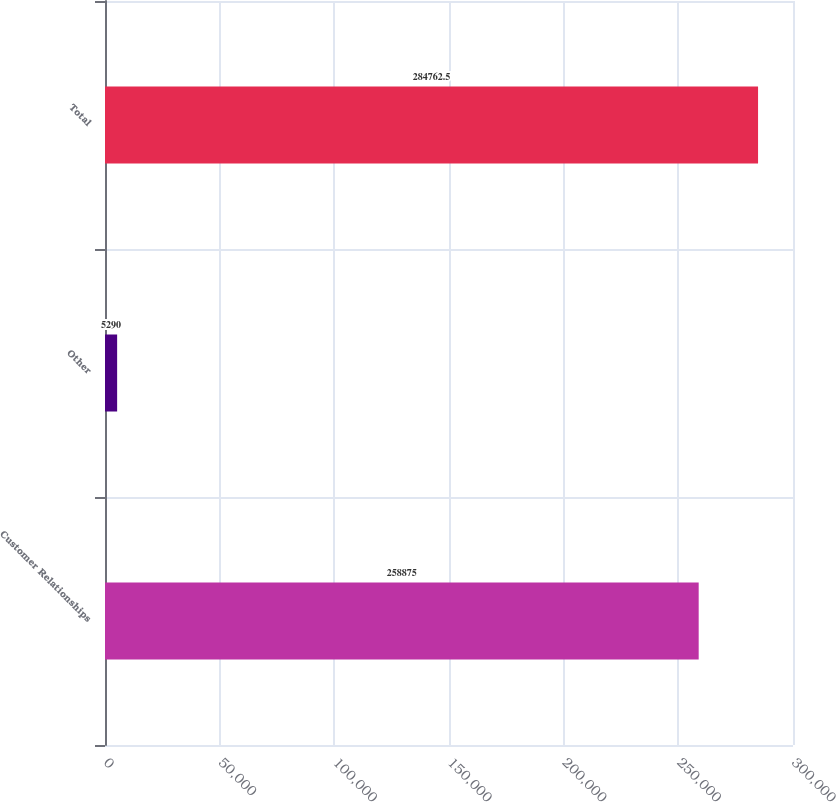Convert chart to OTSL. <chart><loc_0><loc_0><loc_500><loc_500><bar_chart><fcel>Customer Relationships<fcel>Other<fcel>Total<nl><fcel>258875<fcel>5290<fcel>284762<nl></chart> 